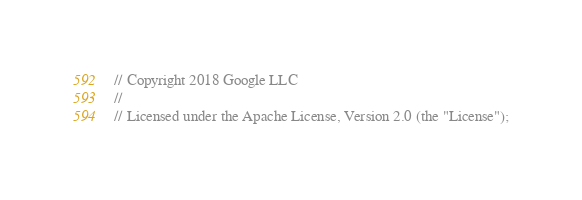<code> <loc_0><loc_0><loc_500><loc_500><_Java_>// Copyright 2018 Google LLC
//
// Licensed under the Apache License, Version 2.0 (the "License");</code> 